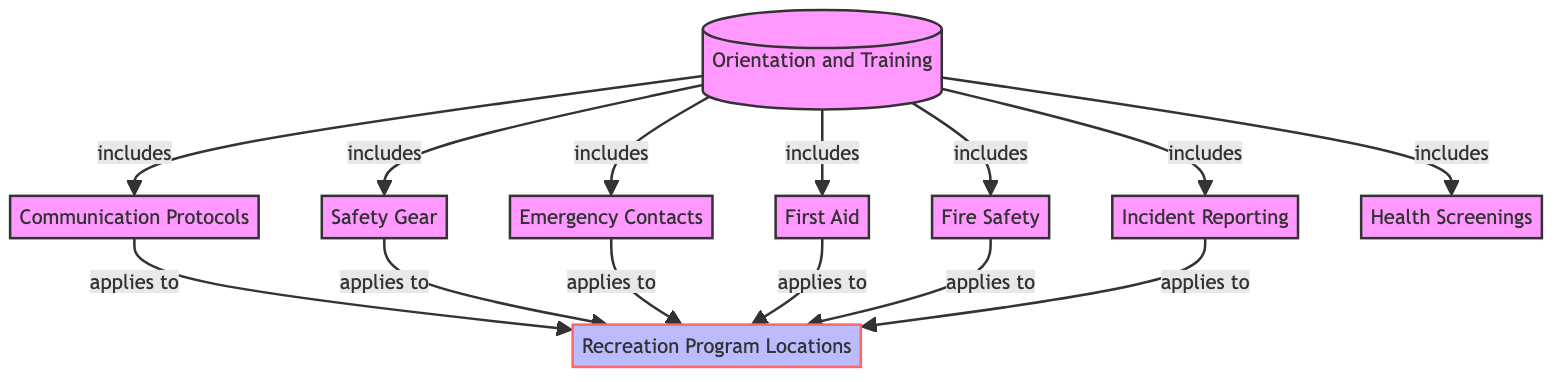What is the total number of nodes in the diagram? The diagram contains a total of 9 nodes, which represent different components of health and safety procedures for community volunteers.
Answer: 9 What relationship does "Orientation and Training" have with "Safety Gear"? The relationship is labeled as "includes," indicating that "Safety Gear" is part of the broader category of "Orientation and Training."
Answer: includes How many relationships are linked to the node "Recreation Program Locations"? The node "Recreation Program Locations" has 6 incoming relationships from nodes such as "Communication Protocols," "Safety Gear," "Emergency Contacts," "First Aid," "Fire Safety," and "Incident Reporting."
Answer: 6 Which node is associated with both "Fire Safety" and "First Aid"? Both of these nodes are linked to "Orientation and Training," as it includes "Fire Safety" and "First Aid."
Answer: Orientation and Training Which node includes the process of "Incident Reporting"? "Incident Reporting" is included in the "Orientation and Training" node, indicating that this procedure is part of the training for volunteers.
Answer: Orientation and Training What type of relationship exists between "Communication Protocols" and "Recreation Program Locations"? The relationship between "Communication Protocols" and "Recreation Program Locations" is described as "applies to," indicating that the communication protocols are relevant to the program locations.
Answer: applies to If a volunteer goes through "Orientation and Training," which health procedure should they also be familiar with? They should be familiar with "First Aid," as it is explicitly included in the "Orientation and Training," along with other safety procedures.
Answer: First Aid Which node does not include any other nodes? The node "Health Screenings" does not include any other nodes, indicating it stands alone in the context of this diagram.
Answer: Health Screenings 